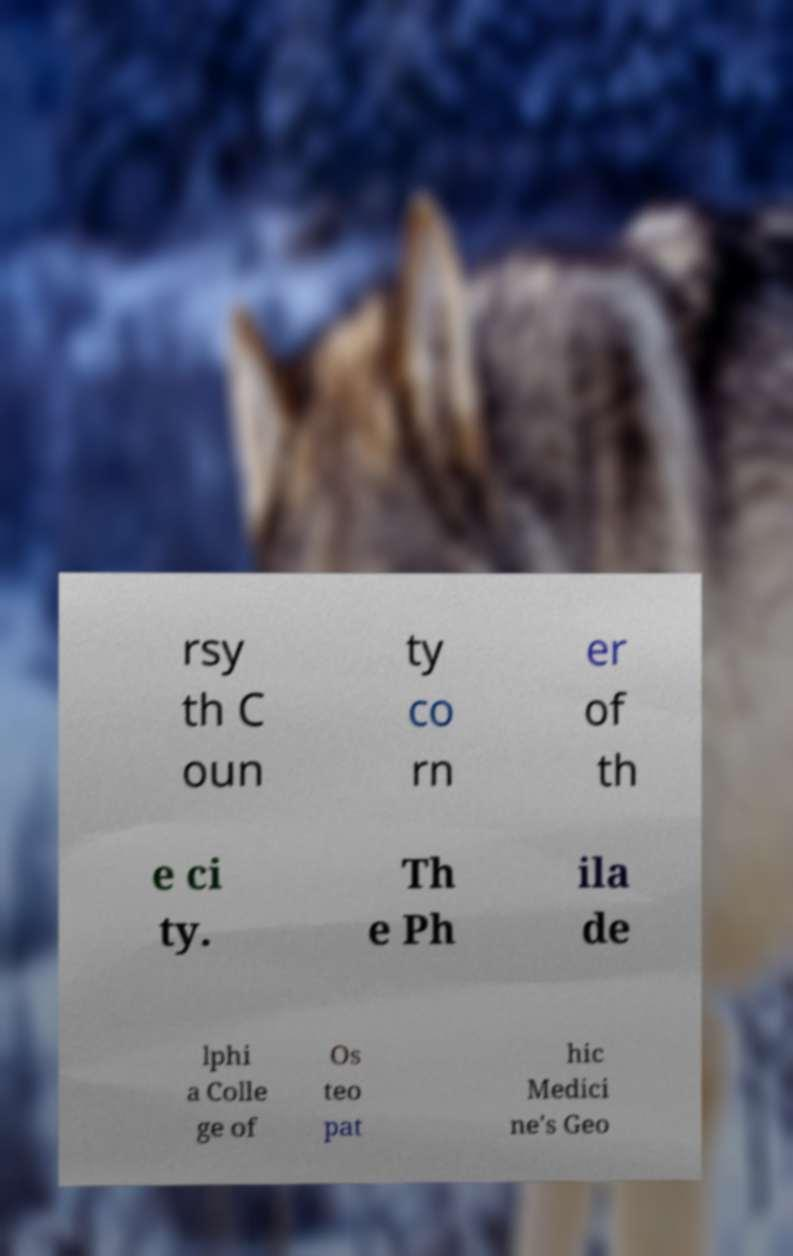There's text embedded in this image that I need extracted. Can you transcribe it verbatim? rsy th C oun ty co rn er of th e ci ty. Th e Ph ila de lphi a Colle ge of Os teo pat hic Medici ne's Geo 